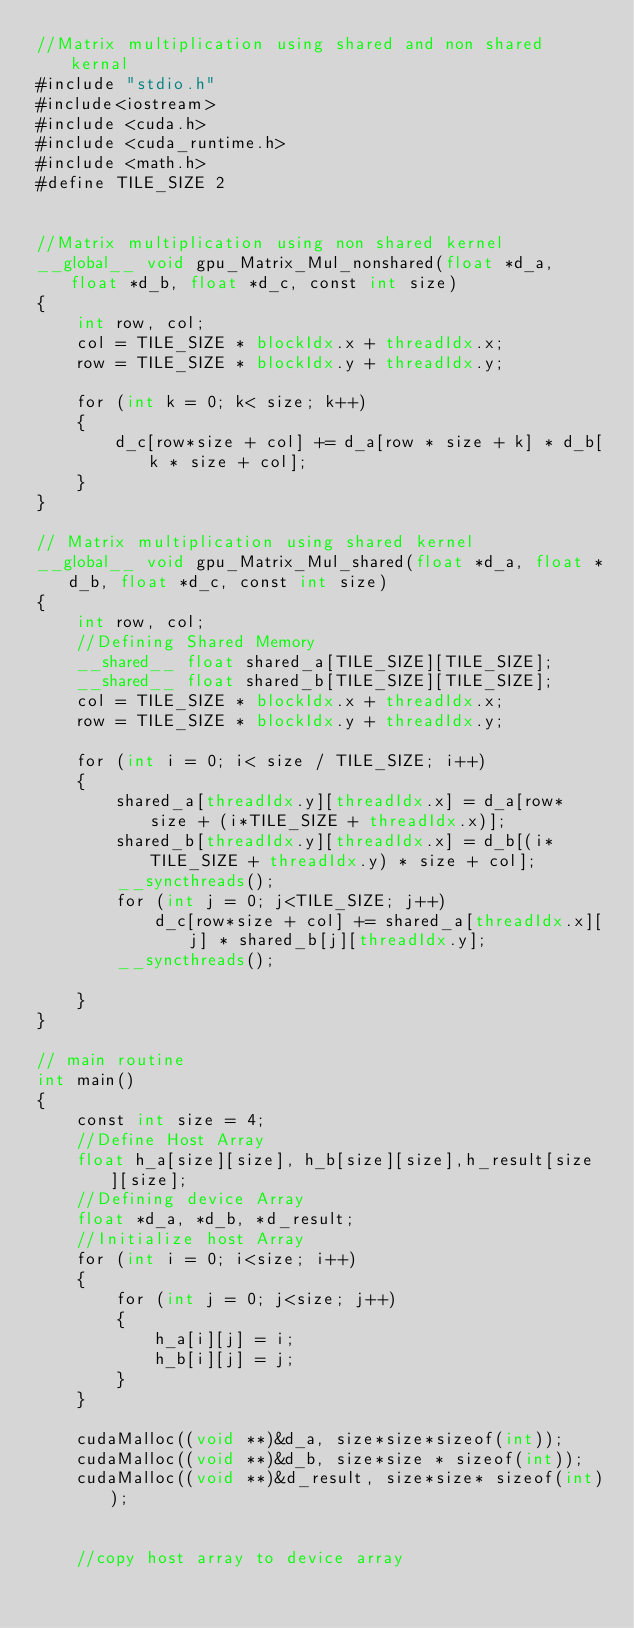Convert code to text. <code><loc_0><loc_0><loc_500><loc_500><_Cuda_>//Matrix multiplication using shared and non shared kernal
#include "stdio.h"
#include<iostream>
#include <cuda.h>
#include <cuda_runtime.h>
#include <math.h>
#define TILE_SIZE 2


//Matrix multiplication using non shared kernel
__global__ void gpu_Matrix_Mul_nonshared(float *d_a, float *d_b, float *d_c, const int size)
{
    int row, col;
    col = TILE_SIZE * blockIdx.x + threadIdx.x;
    row = TILE_SIZE * blockIdx.y + threadIdx.y;

    for (int k = 0; k< size; k++)
    {
        d_c[row*size + col] += d_a[row * size + k] * d_b[k * size + col];
    }
}

// Matrix multiplication using shared kernel
__global__ void gpu_Matrix_Mul_shared(float *d_a, float *d_b, float *d_c, const int size)
{
    int row, col;
    //Defining Shared Memory
    __shared__ float shared_a[TILE_SIZE][TILE_SIZE];
    __shared__ float shared_b[TILE_SIZE][TILE_SIZE];
    col = TILE_SIZE * blockIdx.x + threadIdx.x;
    row = TILE_SIZE * blockIdx.y + threadIdx.y;

    for (int i = 0; i< size / TILE_SIZE; i++)
    {
        shared_a[threadIdx.y][threadIdx.x] = d_a[row* size + (i*TILE_SIZE + threadIdx.x)];
        shared_b[threadIdx.y][threadIdx.x] = d_b[(i*TILE_SIZE + threadIdx.y) * size + col];
        __syncthreads();
        for (int j = 0; j<TILE_SIZE; j++)
            d_c[row*size + col] += shared_a[threadIdx.x][j] * shared_b[j][threadIdx.y];
        __syncthreads();

    }
}

// main routine
int main()
{
    const int size = 4;
    //Define Host Array
    float h_a[size][size], h_b[size][size],h_result[size][size];
    //Defining device Array
    float *d_a, *d_b, *d_result;
    //Initialize host Array
    for (int i = 0; i<size; i++)
    {
        for (int j = 0; j<size; j++)
        {
            h_a[i][j] = i;
            h_b[i][j] = j;
        }
    }

    cudaMalloc((void **)&d_a, size*size*sizeof(int));
    cudaMalloc((void **)&d_b, size*size * sizeof(int));
    cudaMalloc((void **)&d_result, size*size* sizeof(int));


    //copy host array to device array
</code> 